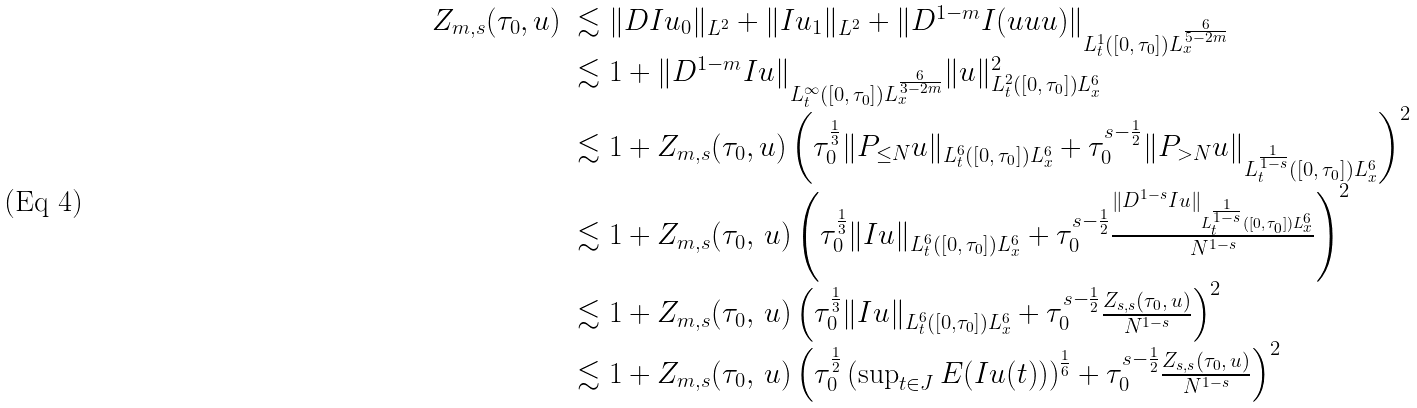<formula> <loc_0><loc_0><loc_500><loc_500>\begin{array} { l l } Z _ { m , s } ( \tau _ { 0 } , u ) & \lesssim \| D I u _ { 0 } \| _ { L ^ { 2 } } + \| I u _ { 1 } \| _ { L ^ { 2 } } + \| D ^ { 1 - m } I ( u u u ) \| _ { L _ { t } ^ { 1 } ( [ 0 , \, \tau _ { 0 } ] ) L _ { x } ^ { \frac { 6 } { 5 - 2 m } } } \\ & \lesssim 1 + \| D ^ { 1 - m } I u \| _ { L _ { t } ^ { \infty } \left ( [ 0 , \, \tau _ { 0 } ] \right ) L _ { x } ^ { \frac { 6 } { 3 - 2 m } } } \| u \| _ { L _ { t } ^ { 2 } \left ( [ 0 , \, \tau _ { 0 } ] \right ) L _ { x } ^ { 6 } } ^ { 2 } \\ & \lesssim 1 + Z _ { m , s } ( \tau _ { 0 } , u ) \left ( \tau _ { 0 } ^ { \frac { 1 } { 3 } } \| P _ { \leq N } u \| _ { L _ { t } ^ { 6 } ( [ 0 , \, \tau _ { 0 } ] ) L _ { x } ^ { 6 } } + \tau _ { 0 } ^ { s - \frac { 1 } { 2 } } \| P _ { > N } u \| _ { L _ { t } ^ { \frac { 1 } { 1 - s } } ( [ 0 , \, \tau _ { 0 } ] ) L _ { x } ^ { 6 } } \right ) ^ { 2 } \\ & \lesssim 1 + Z _ { m , s } ( \tau _ { 0 } , \, u ) \left ( \tau _ { 0 } ^ { \frac { 1 } { 3 } } \| I u \| _ { L _ { t } ^ { 6 } ( [ 0 , \, \tau _ { 0 } ] ) L _ { x } ^ { 6 } } + \tau _ { 0 } ^ { s - \frac { 1 } { 2 } } \frac { \| D ^ { 1 - s } I u \| _ { L _ { t } ^ { \frac { 1 } { 1 - s } } ( [ 0 , \, \tau _ { 0 } ] ) L _ { x } ^ { 6 } } } { N ^ { 1 - s } } \right ) ^ { 2 } \\ & \lesssim 1 + Z _ { m , s } ( \tau _ { 0 } , \, u ) \left ( \tau _ { 0 } ^ { \frac { 1 } { 3 } } \| I u \| _ { L _ { t } ^ { 6 } ( [ 0 , \tau _ { 0 } ] ) L _ { x } ^ { 6 } } + \tau _ { 0 } ^ { s - \frac { 1 } { 2 } } \frac { Z _ { s , s } ( \tau _ { 0 } , \, u ) } { N ^ { 1 - s } } \right ) ^ { 2 } \\ & \lesssim 1 + Z _ { m , s } ( \tau _ { 0 } , \, u ) \left ( \tau _ { 0 } ^ { \frac { 1 } { 2 } } \left ( \sup _ { t \in J } E ( I u ( t ) ) \right ) ^ { \frac { 1 } { 6 } } + \tau _ { 0 } ^ { s - \frac { 1 } { 2 } } \frac { Z _ { s , s } ( \tau _ { 0 } , \, u ) } { N ^ { 1 - s } } \right ) ^ { 2 } \end{array}</formula> 